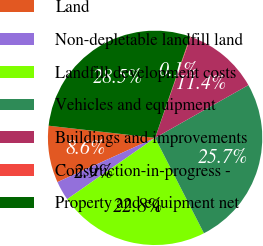Convert chart to OTSL. <chart><loc_0><loc_0><loc_500><loc_500><pie_chart><fcel>Land<fcel>Non-depletable landfill land<fcel>Landfill development costs<fcel>Vehicles and equipment<fcel>Buildings and improvements<fcel>Construction-in-progress -<fcel>Property and equipment net<nl><fcel>8.58%<fcel>2.92%<fcel>22.84%<fcel>25.66%<fcel>11.41%<fcel>0.1%<fcel>28.49%<nl></chart> 